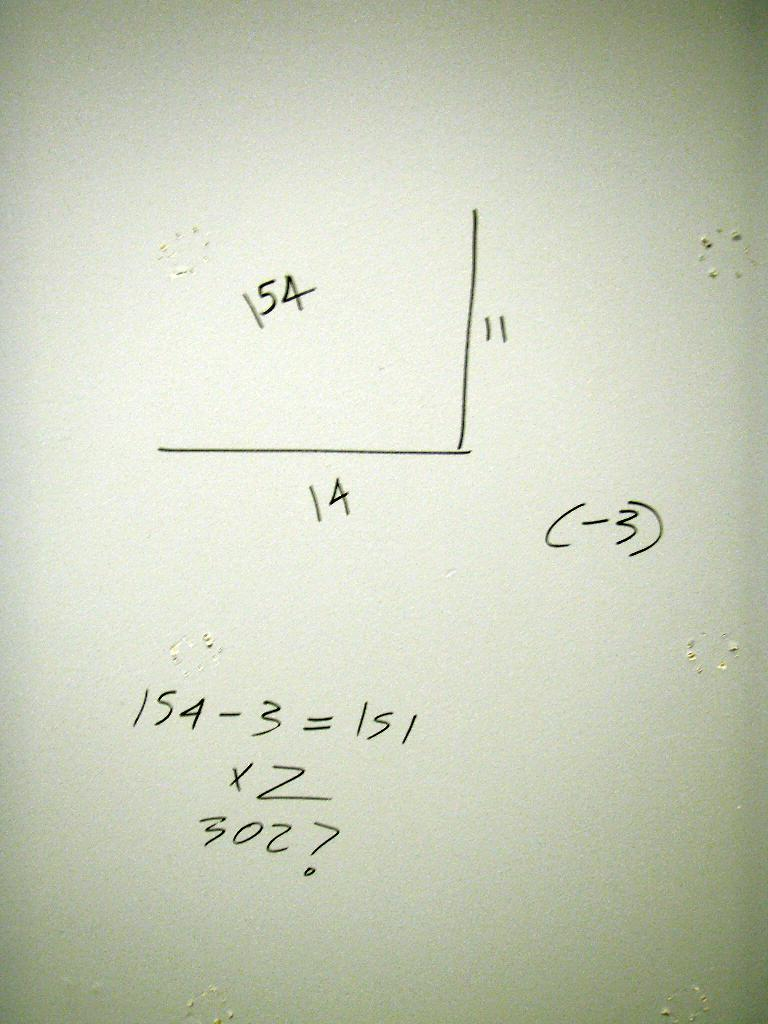<image>
Provide a brief description of the given image. A white board has many letters written on it, including "154". 